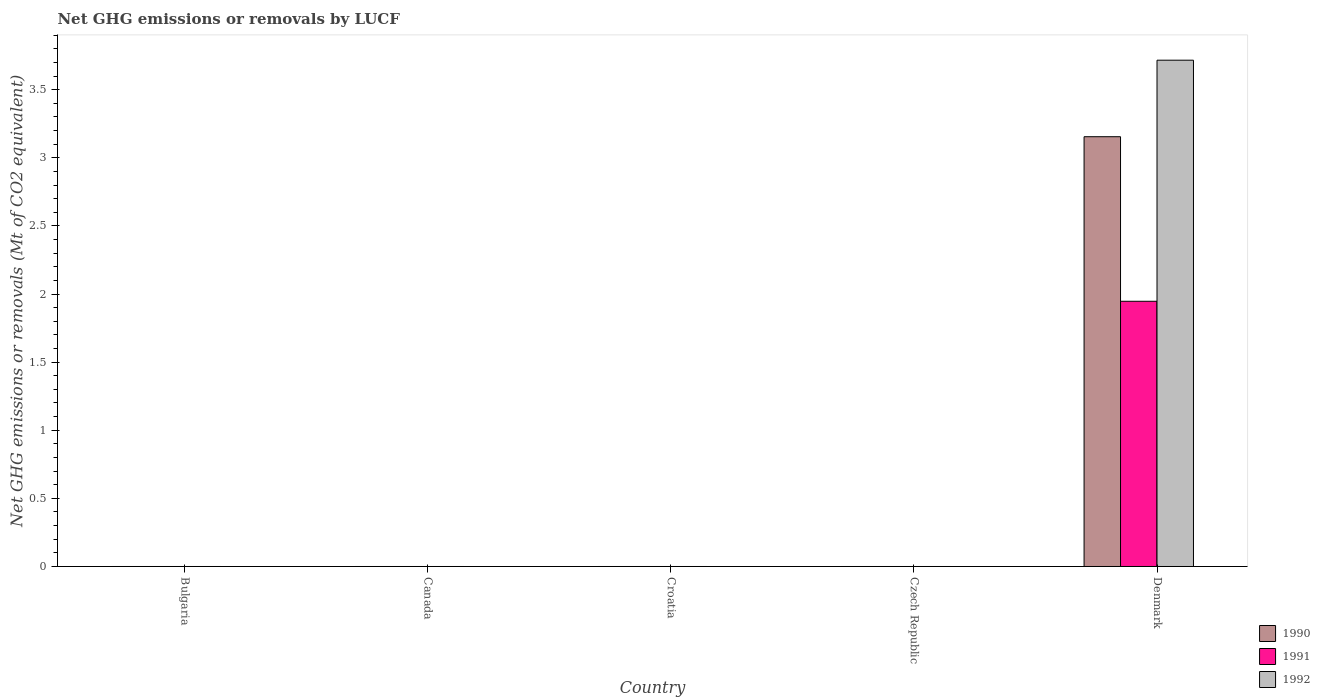Are the number of bars on each tick of the X-axis equal?
Your answer should be compact. No. How many bars are there on the 2nd tick from the left?
Offer a terse response. 0. How many bars are there on the 2nd tick from the right?
Your answer should be very brief. 0. What is the label of the 4th group of bars from the left?
Ensure brevity in your answer.  Czech Republic. In how many cases, is the number of bars for a given country not equal to the number of legend labels?
Give a very brief answer. 4. What is the net GHG emissions or removals by LUCF in 1991 in Canada?
Give a very brief answer. 0. Across all countries, what is the maximum net GHG emissions or removals by LUCF in 1990?
Keep it short and to the point. 3.15. What is the total net GHG emissions or removals by LUCF in 1991 in the graph?
Offer a very short reply. 1.95. What is the average net GHG emissions or removals by LUCF in 1990 per country?
Make the answer very short. 0.63. What is the difference between the net GHG emissions or removals by LUCF of/in 1992 and net GHG emissions or removals by LUCF of/in 1991 in Denmark?
Provide a short and direct response. 1.77. In how many countries, is the net GHG emissions or removals by LUCF in 1991 greater than 3.6 Mt?
Provide a short and direct response. 0. What is the difference between the highest and the lowest net GHG emissions or removals by LUCF in 1990?
Your answer should be very brief. 3.15. Is it the case that in every country, the sum of the net GHG emissions or removals by LUCF in 1991 and net GHG emissions or removals by LUCF in 1990 is greater than the net GHG emissions or removals by LUCF in 1992?
Keep it short and to the point. No. Are the values on the major ticks of Y-axis written in scientific E-notation?
Ensure brevity in your answer.  No. Does the graph contain any zero values?
Offer a very short reply. Yes. How are the legend labels stacked?
Make the answer very short. Vertical. What is the title of the graph?
Your answer should be very brief. Net GHG emissions or removals by LUCF. What is the label or title of the Y-axis?
Ensure brevity in your answer.  Net GHG emissions or removals (Mt of CO2 equivalent). What is the Net GHG emissions or removals (Mt of CO2 equivalent) of 1991 in Canada?
Keep it short and to the point. 0. What is the Net GHG emissions or removals (Mt of CO2 equivalent) of 1990 in Croatia?
Keep it short and to the point. 0. What is the Net GHG emissions or removals (Mt of CO2 equivalent) of 1992 in Croatia?
Provide a succinct answer. 0. What is the Net GHG emissions or removals (Mt of CO2 equivalent) of 1990 in Denmark?
Provide a short and direct response. 3.15. What is the Net GHG emissions or removals (Mt of CO2 equivalent) of 1991 in Denmark?
Your answer should be very brief. 1.95. What is the Net GHG emissions or removals (Mt of CO2 equivalent) of 1992 in Denmark?
Make the answer very short. 3.72. Across all countries, what is the maximum Net GHG emissions or removals (Mt of CO2 equivalent) in 1990?
Offer a terse response. 3.15. Across all countries, what is the maximum Net GHG emissions or removals (Mt of CO2 equivalent) of 1991?
Your response must be concise. 1.95. Across all countries, what is the maximum Net GHG emissions or removals (Mt of CO2 equivalent) of 1992?
Offer a very short reply. 3.72. Across all countries, what is the minimum Net GHG emissions or removals (Mt of CO2 equivalent) of 1991?
Your answer should be very brief. 0. Across all countries, what is the minimum Net GHG emissions or removals (Mt of CO2 equivalent) of 1992?
Offer a terse response. 0. What is the total Net GHG emissions or removals (Mt of CO2 equivalent) in 1990 in the graph?
Provide a short and direct response. 3.15. What is the total Net GHG emissions or removals (Mt of CO2 equivalent) of 1991 in the graph?
Offer a terse response. 1.95. What is the total Net GHG emissions or removals (Mt of CO2 equivalent) in 1992 in the graph?
Your answer should be compact. 3.72. What is the average Net GHG emissions or removals (Mt of CO2 equivalent) in 1990 per country?
Ensure brevity in your answer.  0.63. What is the average Net GHG emissions or removals (Mt of CO2 equivalent) in 1991 per country?
Your response must be concise. 0.39. What is the average Net GHG emissions or removals (Mt of CO2 equivalent) in 1992 per country?
Make the answer very short. 0.74. What is the difference between the Net GHG emissions or removals (Mt of CO2 equivalent) in 1990 and Net GHG emissions or removals (Mt of CO2 equivalent) in 1991 in Denmark?
Keep it short and to the point. 1.21. What is the difference between the Net GHG emissions or removals (Mt of CO2 equivalent) in 1990 and Net GHG emissions or removals (Mt of CO2 equivalent) in 1992 in Denmark?
Make the answer very short. -0.56. What is the difference between the Net GHG emissions or removals (Mt of CO2 equivalent) of 1991 and Net GHG emissions or removals (Mt of CO2 equivalent) of 1992 in Denmark?
Provide a succinct answer. -1.77. What is the difference between the highest and the lowest Net GHG emissions or removals (Mt of CO2 equivalent) of 1990?
Keep it short and to the point. 3.15. What is the difference between the highest and the lowest Net GHG emissions or removals (Mt of CO2 equivalent) of 1991?
Keep it short and to the point. 1.95. What is the difference between the highest and the lowest Net GHG emissions or removals (Mt of CO2 equivalent) of 1992?
Your answer should be compact. 3.72. 